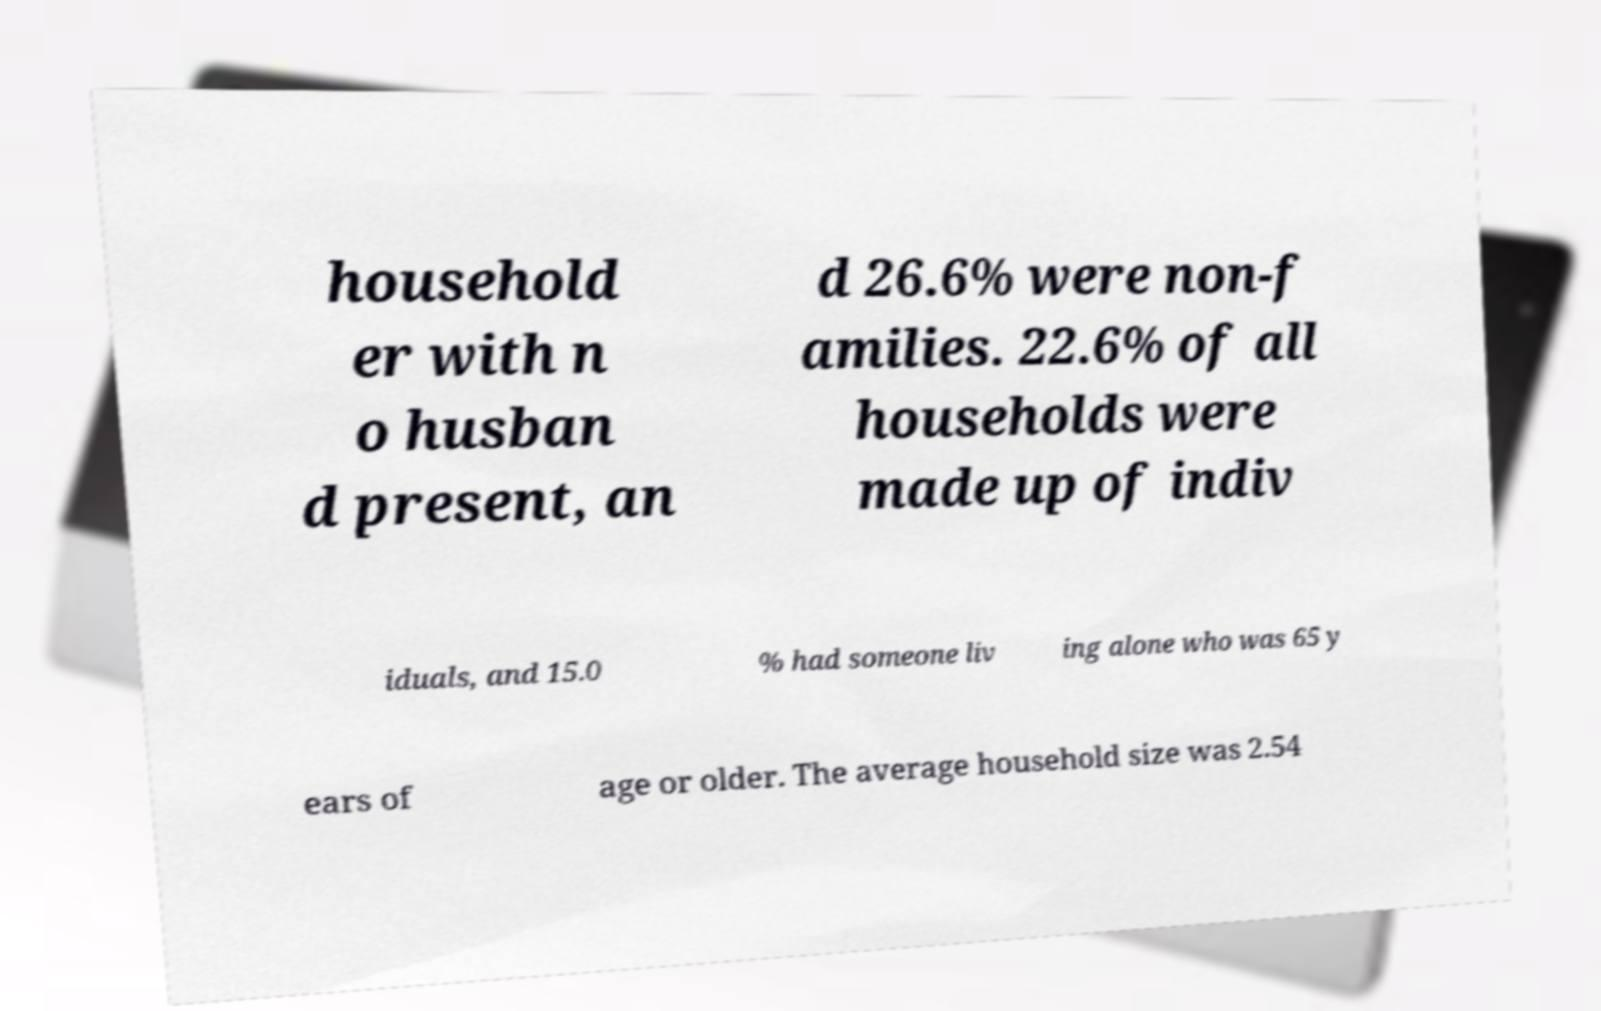Could you assist in decoding the text presented in this image and type it out clearly? household er with n o husban d present, an d 26.6% were non-f amilies. 22.6% of all households were made up of indiv iduals, and 15.0 % had someone liv ing alone who was 65 y ears of age or older. The average household size was 2.54 